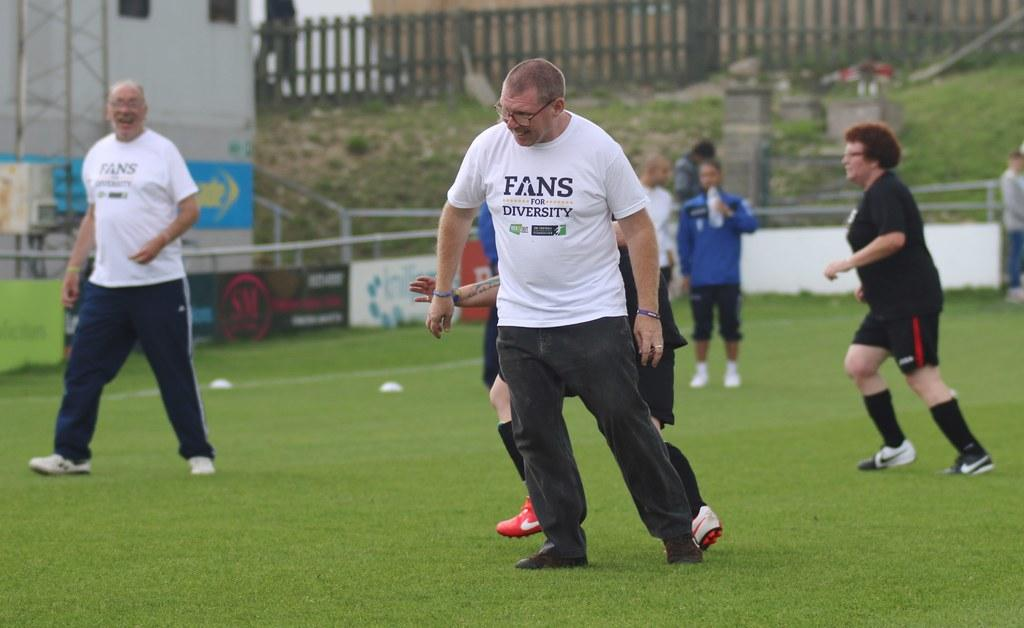<image>
Offer a succinct explanation of the picture presented. A man on a sports field wears a shirt that says "Fans for Diversity". 